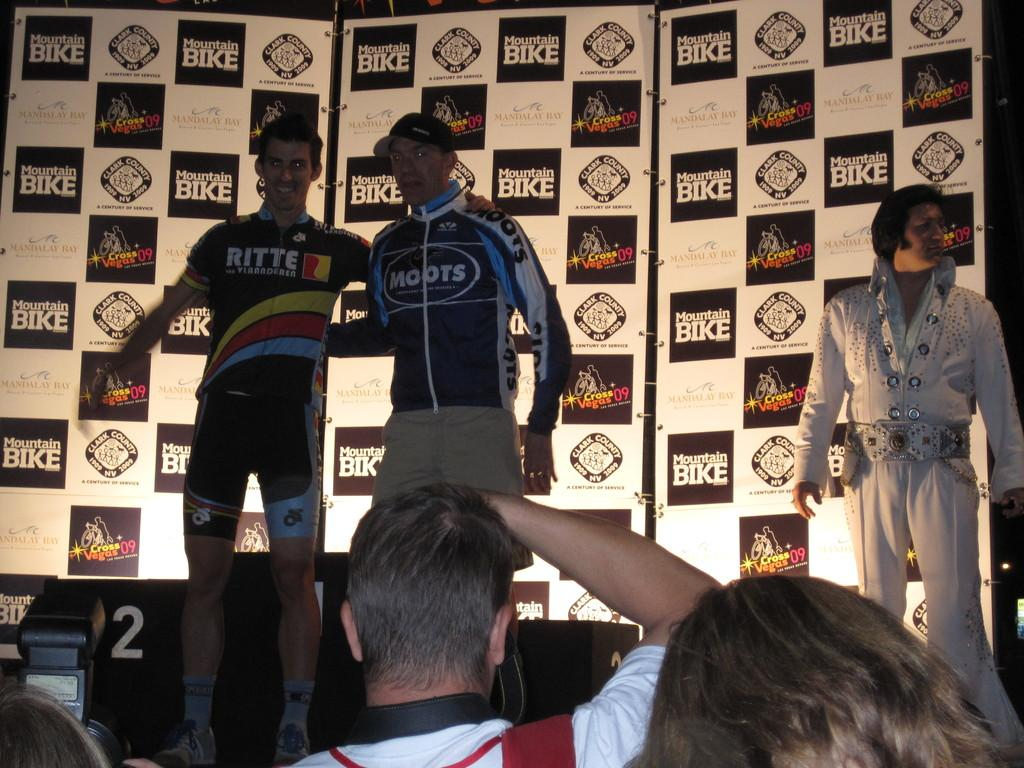Provide a one-sentence caption for the provided image. Men standing on a stage with one wearing a jacket that says RITTE on it. 